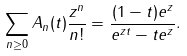Convert formula to latex. <formula><loc_0><loc_0><loc_500><loc_500>\sum _ { n \geq 0 } A _ { n } ( t ) \frac { z ^ { n } } { n ! } = \frac { ( 1 - t ) e ^ { z } } { e ^ { z t } - t e ^ { z } } .</formula> 